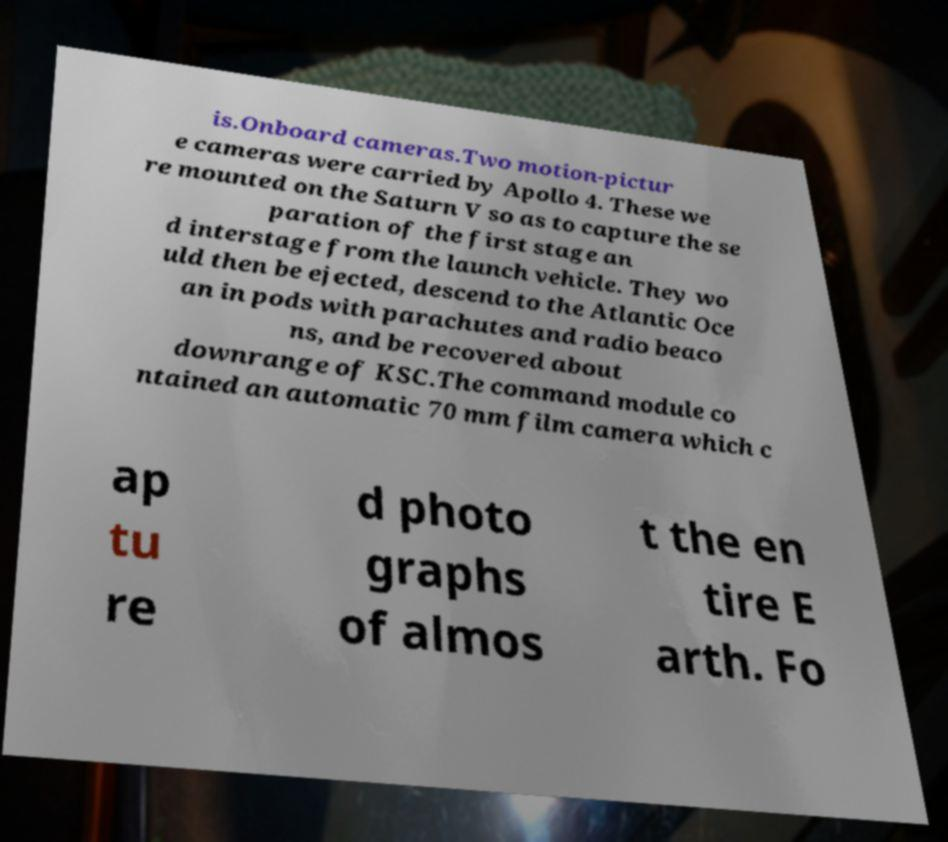For documentation purposes, I need the text within this image transcribed. Could you provide that? is.Onboard cameras.Two motion-pictur e cameras were carried by Apollo 4. These we re mounted on the Saturn V so as to capture the se paration of the first stage an d interstage from the launch vehicle. They wo uld then be ejected, descend to the Atlantic Oce an in pods with parachutes and radio beaco ns, and be recovered about downrange of KSC.The command module co ntained an automatic 70 mm film camera which c ap tu re d photo graphs of almos t the en tire E arth. Fo 